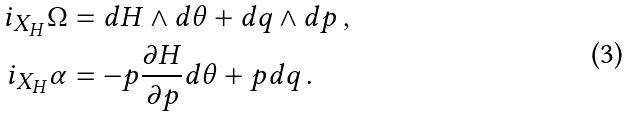<formula> <loc_0><loc_0><loc_500><loc_500>i _ { X _ { H } } \Omega & = d H \wedge d \theta + d q \wedge d p \, , \\ i _ { X _ { H } } \alpha & = - p \frac { \partial H } { \partial p } d \theta + p d q \, .</formula> 